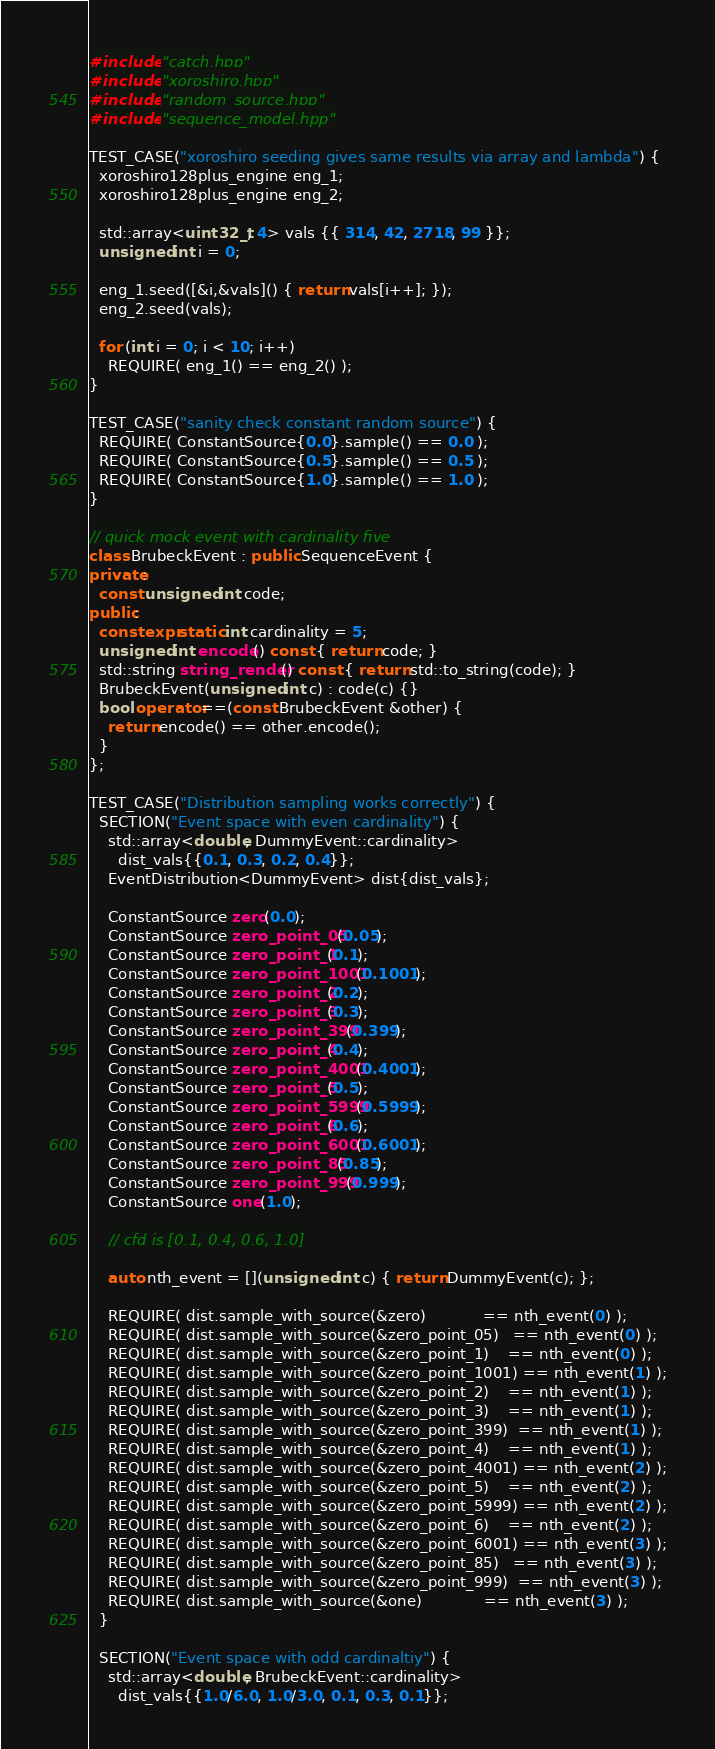<code> <loc_0><loc_0><loc_500><loc_500><_C++_>#include "catch.hpp"
#include "xoroshiro.hpp"
#include "random_source.hpp"
#include "sequence_model.hpp"

TEST_CASE("xoroshiro seeding gives same results via array and lambda") {
  xoroshiro128plus_engine eng_1;
  xoroshiro128plus_engine eng_2;

  std::array<uint32_t, 4> vals {{ 314, 42, 2718, 99 }};
  unsigned int i = 0;

  eng_1.seed([&i,&vals]() { return vals[i++]; });
  eng_2.seed(vals);

  for (int i = 0; i < 10; i++)
    REQUIRE( eng_1() == eng_2() );
}

TEST_CASE("sanity check constant random source") {
  REQUIRE( ConstantSource{0.0}.sample() == 0.0 );
  REQUIRE( ConstantSource{0.5}.sample() == 0.5 );
  REQUIRE( ConstantSource{1.0}.sample() == 1.0 );
}

// quick mock event with cardinality five
class BrubeckEvent : public SequenceEvent {
private:
  const unsigned int code;
public:
  constexpr static int cardinality = 5;
  unsigned int encode() const { return code; }
  std::string string_render() const { return std::to_string(code); }
  BrubeckEvent(unsigned int c) : code(c) {}
  bool operator==(const BrubeckEvent &other) {
    return encode() == other.encode();
  }
};

TEST_CASE("Distribution sampling works correctly") {
  SECTION("Event space with even cardinality") {
    std::array<double, DummyEvent::cardinality>
      dist_vals{{0.1, 0.3, 0.2, 0.4}};
    EventDistribution<DummyEvent> dist{dist_vals};

    ConstantSource zero(0.0);
    ConstantSource zero_point_05(0.05);
    ConstantSource zero_point_1(0.1);
    ConstantSource zero_point_1001(0.1001);
    ConstantSource zero_point_2(0.2);
    ConstantSource zero_point_3(0.3);
    ConstantSource zero_point_399(0.399);
    ConstantSource zero_point_4(0.4);
    ConstantSource zero_point_4001(0.4001);
    ConstantSource zero_point_5(0.5);
    ConstantSource zero_point_5999(0.5999);
    ConstantSource zero_point_6(0.6);
    ConstantSource zero_point_6001(0.6001);
    ConstantSource zero_point_85(0.85);
    ConstantSource zero_point_999(0.999);
    ConstantSource one(1.0);
    
    // cfd is [0.1, 0.4, 0.6, 1.0]

    auto nth_event = [](unsigned int c) { return DummyEvent(c); };

    REQUIRE( dist.sample_with_source(&zero)            == nth_event(0) );
    REQUIRE( dist.sample_with_source(&zero_point_05)   == nth_event(0) );
    REQUIRE( dist.sample_with_source(&zero_point_1)    == nth_event(0) );
    REQUIRE( dist.sample_with_source(&zero_point_1001) == nth_event(1) );
    REQUIRE( dist.sample_with_source(&zero_point_2)    == nth_event(1) );
    REQUIRE( dist.sample_with_source(&zero_point_3)    == nth_event(1) );
    REQUIRE( dist.sample_with_source(&zero_point_399)  == nth_event(1) );
    REQUIRE( dist.sample_with_source(&zero_point_4)    == nth_event(1) );
    REQUIRE( dist.sample_with_source(&zero_point_4001) == nth_event(2) );
    REQUIRE( dist.sample_with_source(&zero_point_5)    == nth_event(2) );
    REQUIRE( dist.sample_with_source(&zero_point_5999) == nth_event(2) );
    REQUIRE( dist.sample_with_source(&zero_point_6)    == nth_event(2) );
    REQUIRE( dist.sample_with_source(&zero_point_6001) == nth_event(3) );
    REQUIRE( dist.sample_with_source(&zero_point_85)   == nth_event(3) );
    REQUIRE( dist.sample_with_source(&zero_point_999)  == nth_event(3) );
    REQUIRE( dist.sample_with_source(&one)             == nth_event(3) );
  }
  
  SECTION("Event space with odd cardinaltiy") {
    std::array<double, BrubeckEvent::cardinality>
      dist_vals{{1.0/6.0, 1.0/3.0, 0.1, 0.3, 0.1}};</code> 